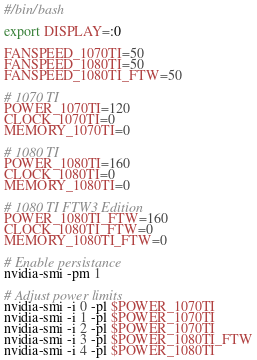<code> <loc_0><loc_0><loc_500><loc_500><_Bash_>#/bin/bash

export DISPLAY=:0

FANSPEED_1070TI=50
FANSPEED_1080TI=50
FANSPEED_1080TI_FTW=50

# 1070 TI
POWER_1070TI=120
CLOCK_1070TI=0
MEMORY_1070TI=0

# 1080 TI
POWER_1080TI=160
CLOCK_1080TI=0
MEMORY_1080TI=0

# 1080 TI FTW3 Edition
POWER_1080TI_FTW=160
CLOCK_1080TI_FTW=0
MEMORY_1080TI_FTW=0

# Enable persistance
nvidia-smi -pm 1

# Adjust power limits
nvidia-smi -i 0 -pl $POWER_1070TI
nvidia-smi -i 1 -pl $POWER_1070TI
nvidia-smi -i 2 -pl $POWER_1070TI
nvidia-smi -i 3 -pl $POWER_1080TI_FTW
nvidia-smi -i 4 -pl $POWER_1080TI</code> 